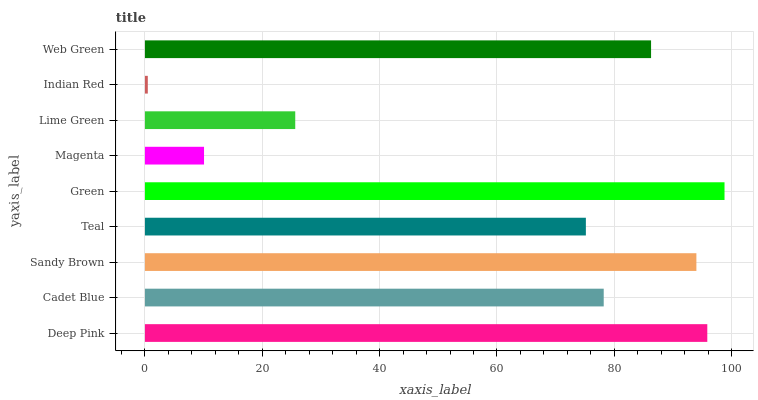Is Indian Red the minimum?
Answer yes or no. Yes. Is Green the maximum?
Answer yes or no. Yes. Is Cadet Blue the minimum?
Answer yes or no. No. Is Cadet Blue the maximum?
Answer yes or no. No. Is Deep Pink greater than Cadet Blue?
Answer yes or no. Yes. Is Cadet Blue less than Deep Pink?
Answer yes or no. Yes. Is Cadet Blue greater than Deep Pink?
Answer yes or no. No. Is Deep Pink less than Cadet Blue?
Answer yes or no. No. Is Cadet Blue the high median?
Answer yes or no. Yes. Is Cadet Blue the low median?
Answer yes or no. Yes. Is Web Green the high median?
Answer yes or no. No. Is Teal the low median?
Answer yes or no. No. 